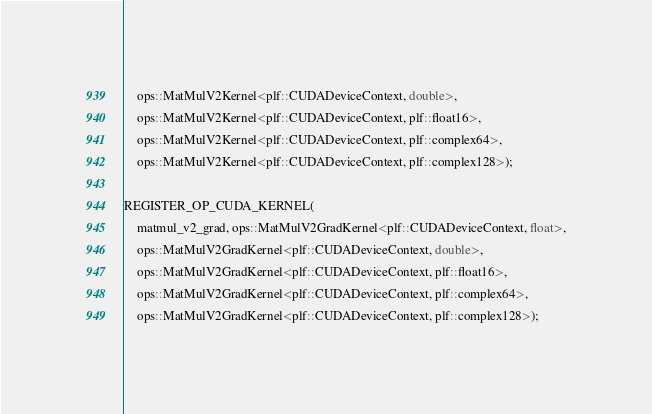Convert code to text. <code><loc_0><loc_0><loc_500><loc_500><_Cuda_>    ops::MatMulV2Kernel<plf::CUDADeviceContext, double>,
    ops::MatMulV2Kernel<plf::CUDADeviceContext, plf::float16>,
    ops::MatMulV2Kernel<plf::CUDADeviceContext, plf::complex64>,
    ops::MatMulV2Kernel<plf::CUDADeviceContext, plf::complex128>);

REGISTER_OP_CUDA_KERNEL(
    matmul_v2_grad, ops::MatMulV2GradKernel<plf::CUDADeviceContext, float>,
    ops::MatMulV2GradKernel<plf::CUDADeviceContext, double>,
    ops::MatMulV2GradKernel<plf::CUDADeviceContext, plf::float16>,
    ops::MatMulV2GradKernel<plf::CUDADeviceContext, plf::complex64>,
    ops::MatMulV2GradKernel<plf::CUDADeviceContext, plf::complex128>);
</code> 